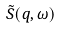Convert formula to latex. <formula><loc_0><loc_0><loc_500><loc_500>\tilde { S } ( q , \omega )</formula> 